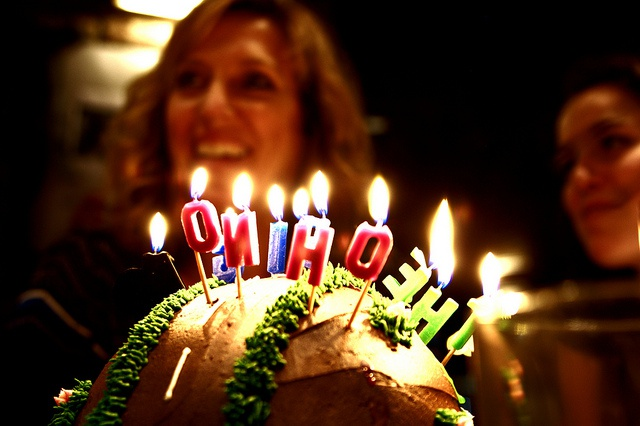Describe the objects in this image and their specific colors. I can see people in black, maroon, and brown tones, cake in black, maroon, beige, and khaki tones, and people in black, maroon, and brown tones in this image. 